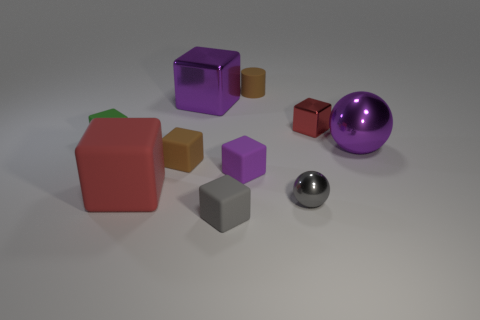Are there any other red things of the same shape as the red rubber object?
Offer a terse response. Yes. What material is the tiny cylinder?
Make the answer very short. Rubber. What size is the object that is both right of the purple rubber block and in front of the large matte block?
Your answer should be very brief. Small. There is a object that is the same color as the tiny metal cube; what material is it?
Your answer should be compact. Rubber. What number of big rubber balls are there?
Provide a short and direct response. 0. Is the number of brown rubber cylinders less than the number of small cyan objects?
Make the answer very short. No. What material is the purple ball that is the same size as the red rubber block?
Your answer should be very brief. Metal. How many things are either small things or small cylinders?
Make the answer very short. 7. How many things are in front of the large purple shiny cube and left of the tiny brown cylinder?
Make the answer very short. 5. Are there fewer large metallic things that are right of the purple rubber block than purple objects?
Offer a terse response. Yes. 